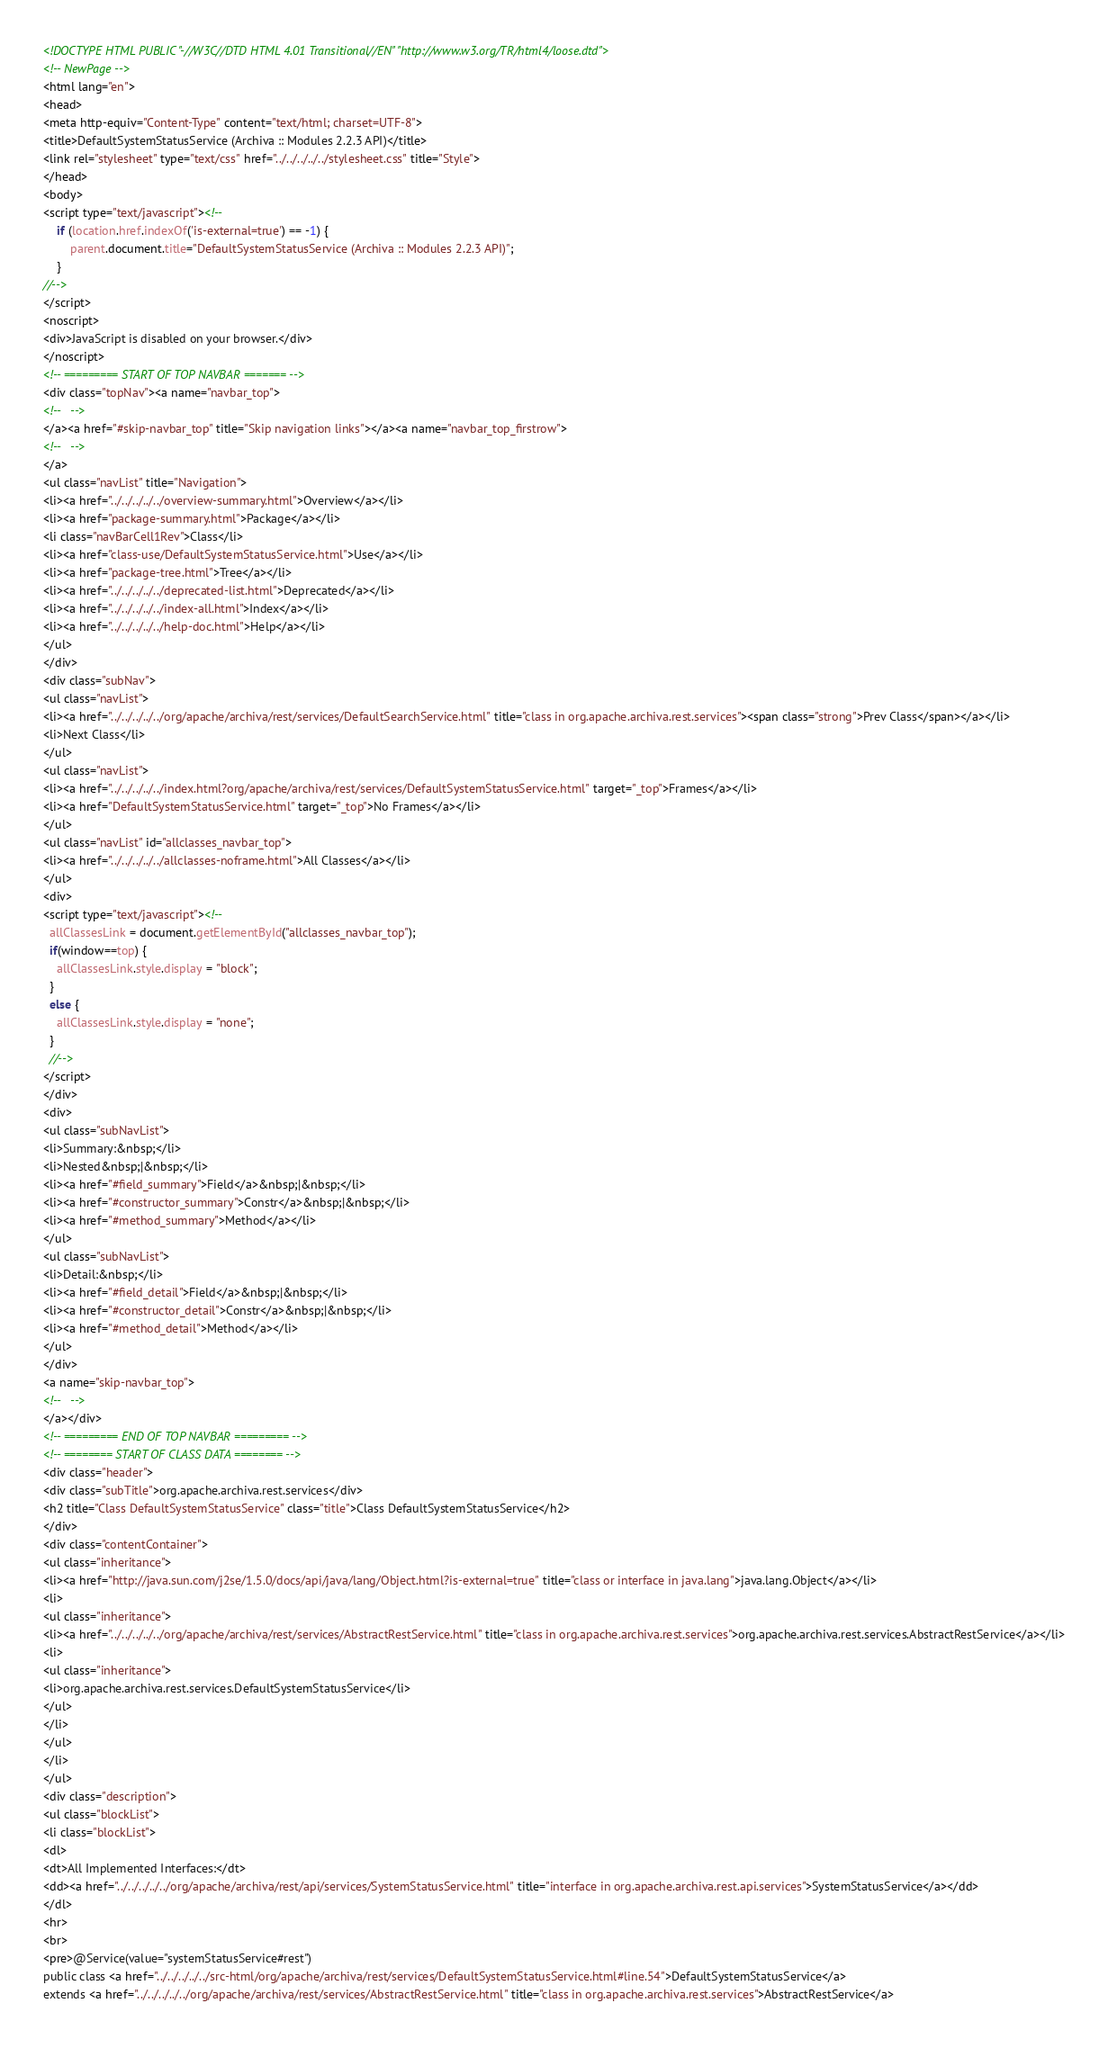<code> <loc_0><loc_0><loc_500><loc_500><_HTML_><!DOCTYPE HTML PUBLIC "-//W3C//DTD HTML 4.01 Transitional//EN" "http://www.w3.org/TR/html4/loose.dtd">
<!-- NewPage -->
<html lang="en">
<head>
<meta http-equiv="Content-Type" content="text/html; charset=UTF-8">
<title>DefaultSystemStatusService (Archiva :: Modules 2.2.3 API)</title>
<link rel="stylesheet" type="text/css" href="../../../../../stylesheet.css" title="Style">
</head>
<body>
<script type="text/javascript"><!--
    if (location.href.indexOf('is-external=true') == -1) {
        parent.document.title="DefaultSystemStatusService (Archiva :: Modules 2.2.3 API)";
    }
//-->
</script>
<noscript>
<div>JavaScript is disabled on your browser.</div>
</noscript>
<!-- ========= START OF TOP NAVBAR ======= -->
<div class="topNav"><a name="navbar_top">
<!--   -->
</a><a href="#skip-navbar_top" title="Skip navigation links"></a><a name="navbar_top_firstrow">
<!--   -->
</a>
<ul class="navList" title="Navigation">
<li><a href="../../../../../overview-summary.html">Overview</a></li>
<li><a href="package-summary.html">Package</a></li>
<li class="navBarCell1Rev">Class</li>
<li><a href="class-use/DefaultSystemStatusService.html">Use</a></li>
<li><a href="package-tree.html">Tree</a></li>
<li><a href="../../../../../deprecated-list.html">Deprecated</a></li>
<li><a href="../../../../../index-all.html">Index</a></li>
<li><a href="../../../../../help-doc.html">Help</a></li>
</ul>
</div>
<div class="subNav">
<ul class="navList">
<li><a href="../../../../../org/apache/archiva/rest/services/DefaultSearchService.html" title="class in org.apache.archiva.rest.services"><span class="strong">Prev Class</span></a></li>
<li>Next Class</li>
</ul>
<ul class="navList">
<li><a href="../../../../../index.html?org/apache/archiva/rest/services/DefaultSystemStatusService.html" target="_top">Frames</a></li>
<li><a href="DefaultSystemStatusService.html" target="_top">No Frames</a></li>
</ul>
<ul class="navList" id="allclasses_navbar_top">
<li><a href="../../../../../allclasses-noframe.html">All Classes</a></li>
</ul>
<div>
<script type="text/javascript"><!--
  allClassesLink = document.getElementById("allclasses_navbar_top");
  if(window==top) {
    allClassesLink.style.display = "block";
  }
  else {
    allClassesLink.style.display = "none";
  }
  //-->
</script>
</div>
<div>
<ul class="subNavList">
<li>Summary:&nbsp;</li>
<li>Nested&nbsp;|&nbsp;</li>
<li><a href="#field_summary">Field</a>&nbsp;|&nbsp;</li>
<li><a href="#constructor_summary">Constr</a>&nbsp;|&nbsp;</li>
<li><a href="#method_summary">Method</a></li>
</ul>
<ul class="subNavList">
<li>Detail:&nbsp;</li>
<li><a href="#field_detail">Field</a>&nbsp;|&nbsp;</li>
<li><a href="#constructor_detail">Constr</a>&nbsp;|&nbsp;</li>
<li><a href="#method_detail">Method</a></li>
</ul>
</div>
<a name="skip-navbar_top">
<!--   -->
</a></div>
<!-- ========= END OF TOP NAVBAR ========= -->
<!-- ======== START OF CLASS DATA ======== -->
<div class="header">
<div class="subTitle">org.apache.archiva.rest.services</div>
<h2 title="Class DefaultSystemStatusService" class="title">Class DefaultSystemStatusService</h2>
</div>
<div class="contentContainer">
<ul class="inheritance">
<li><a href="http://java.sun.com/j2se/1.5.0/docs/api/java/lang/Object.html?is-external=true" title="class or interface in java.lang">java.lang.Object</a></li>
<li>
<ul class="inheritance">
<li><a href="../../../../../org/apache/archiva/rest/services/AbstractRestService.html" title="class in org.apache.archiva.rest.services">org.apache.archiva.rest.services.AbstractRestService</a></li>
<li>
<ul class="inheritance">
<li>org.apache.archiva.rest.services.DefaultSystemStatusService</li>
</ul>
</li>
</ul>
</li>
</ul>
<div class="description">
<ul class="blockList">
<li class="blockList">
<dl>
<dt>All Implemented Interfaces:</dt>
<dd><a href="../../../../../org/apache/archiva/rest/api/services/SystemStatusService.html" title="interface in org.apache.archiva.rest.api.services">SystemStatusService</a></dd>
</dl>
<hr>
<br>
<pre>@Service(value="systemStatusService#rest")
public class <a href="../../../../../src-html/org/apache/archiva/rest/services/DefaultSystemStatusService.html#line.54">DefaultSystemStatusService</a>
extends <a href="../../../../../org/apache/archiva/rest/services/AbstractRestService.html" title="class in org.apache.archiva.rest.services">AbstractRestService</a></code> 